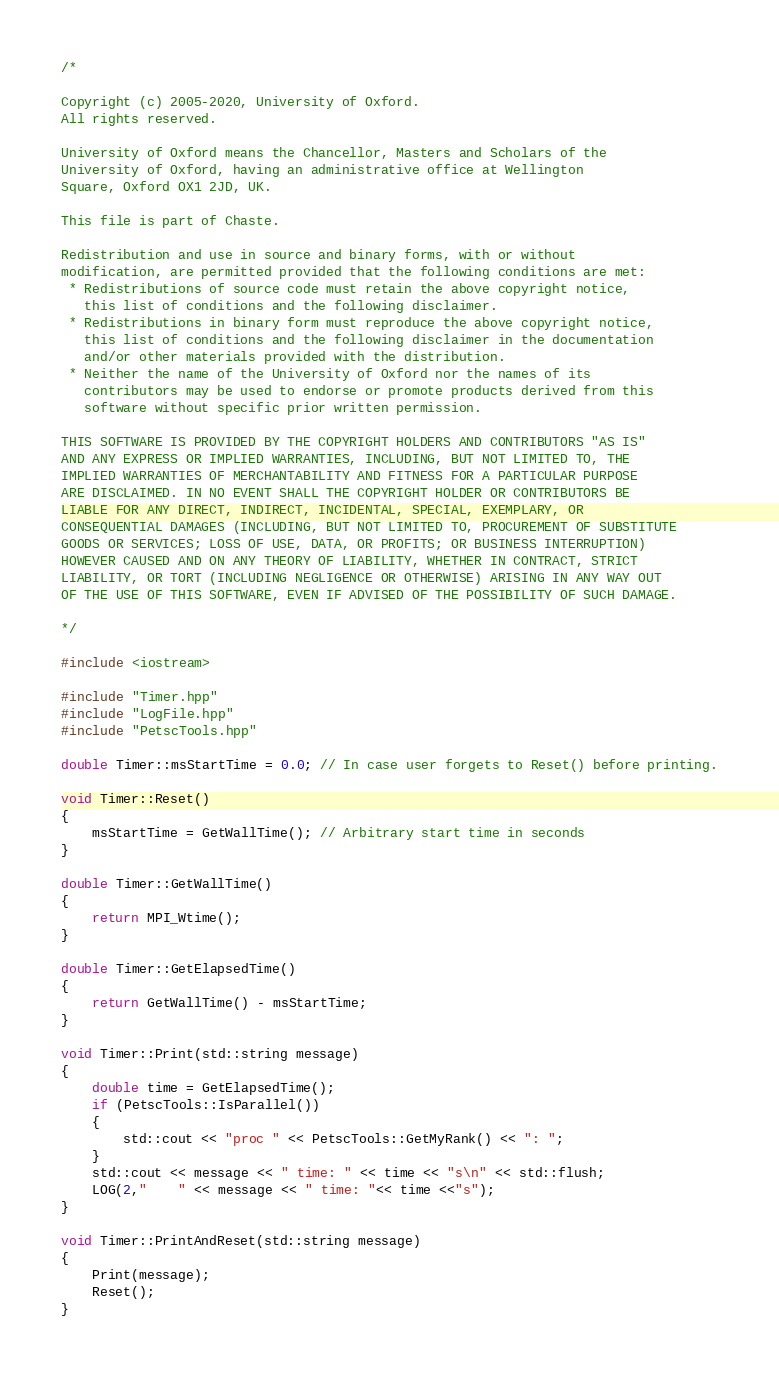<code> <loc_0><loc_0><loc_500><loc_500><_C++_>/*

Copyright (c) 2005-2020, University of Oxford.
All rights reserved.

University of Oxford means the Chancellor, Masters and Scholars of the
University of Oxford, having an administrative office at Wellington
Square, Oxford OX1 2JD, UK.

This file is part of Chaste.

Redistribution and use in source and binary forms, with or without
modification, are permitted provided that the following conditions are met:
 * Redistributions of source code must retain the above copyright notice,
   this list of conditions and the following disclaimer.
 * Redistributions in binary form must reproduce the above copyright notice,
   this list of conditions and the following disclaimer in the documentation
   and/or other materials provided with the distribution.
 * Neither the name of the University of Oxford nor the names of its
   contributors may be used to endorse or promote products derived from this
   software without specific prior written permission.

THIS SOFTWARE IS PROVIDED BY THE COPYRIGHT HOLDERS AND CONTRIBUTORS "AS IS"
AND ANY EXPRESS OR IMPLIED WARRANTIES, INCLUDING, BUT NOT LIMITED TO, THE
IMPLIED WARRANTIES OF MERCHANTABILITY AND FITNESS FOR A PARTICULAR PURPOSE
ARE DISCLAIMED. IN NO EVENT SHALL THE COPYRIGHT HOLDER OR CONTRIBUTORS BE
LIABLE FOR ANY DIRECT, INDIRECT, INCIDENTAL, SPECIAL, EXEMPLARY, OR
CONSEQUENTIAL DAMAGES (INCLUDING, BUT NOT LIMITED TO, PROCUREMENT OF SUBSTITUTE
GOODS OR SERVICES; LOSS OF USE, DATA, OR PROFITS; OR BUSINESS INTERRUPTION)
HOWEVER CAUSED AND ON ANY THEORY OF LIABILITY, WHETHER IN CONTRACT, STRICT
LIABILITY, OR TORT (INCLUDING NEGLIGENCE OR OTHERWISE) ARISING IN ANY WAY OUT
OF THE USE OF THIS SOFTWARE, EVEN IF ADVISED OF THE POSSIBILITY OF SUCH DAMAGE.

*/

#include <iostream>

#include "Timer.hpp"
#include "LogFile.hpp"
#include "PetscTools.hpp"

double Timer::msStartTime = 0.0; // In case user forgets to Reset() before printing.

void Timer::Reset()
{
    msStartTime = GetWallTime(); // Arbitrary start time in seconds
}

double Timer::GetWallTime()
{
    return MPI_Wtime();
}

double Timer::GetElapsedTime()
{
    return GetWallTime() - msStartTime;
}

void Timer::Print(std::string message)
{
    double time = GetElapsedTime();
    if (PetscTools::IsParallel())
    {
        std::cout << "proc " << PetscTools::GetMyRank() << ": ";
    }
    std::cout << message << " time: " << time << "s\n" << std::flush;
    LOG(2,"    " << message << " time: "<< time <<"s");
}

void Timer::PrintAndReset(std::string message)
{
    Print(message);
    Reset();
}
</code> 